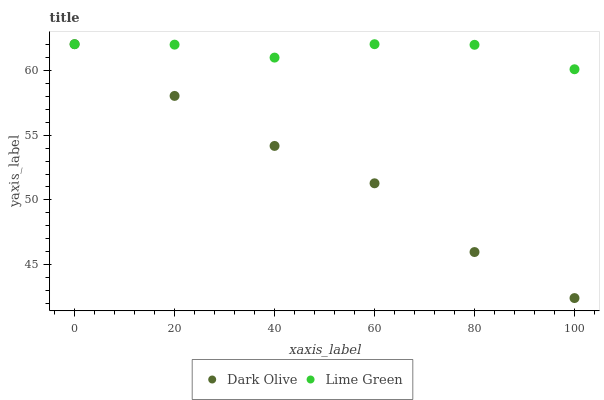Does Dark Olive have the minimum area under the curve?
Answer yes or no. Yes. Does Lime Green have the maximum area under the curve?
Answer yes or no. Yes. Does Lime Green have the minimum area under the curve?
Answer yes or no. No. Is Dark Olive the smoothest?
Answer yes or no. Yes. Is Lime Green the roughest?
Answer yes or no. Yes. Is Lime Green the smoothest?
Answer yes or no. No. Does Dark Olive have the lowest value?
Answer yes or no. Yes. Does Lime Green have the lowest value?
Answer yes or no. No. Does Lime Green have the highest value?
Answer yes or no. Yes. Does Lime Green intersect Dark Olive?
Answer yes or no. Yes. Is Lime Green less than Dark Olive?
Answer yes or no. No. Is Lime Green greater than Dark Olive?
Answer yes or no. No. 